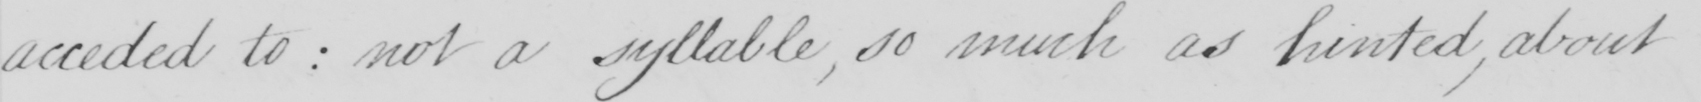Transcribe the text shown in this historical manuscript line. acceded to :  not a syllable , so much as hinted , about 